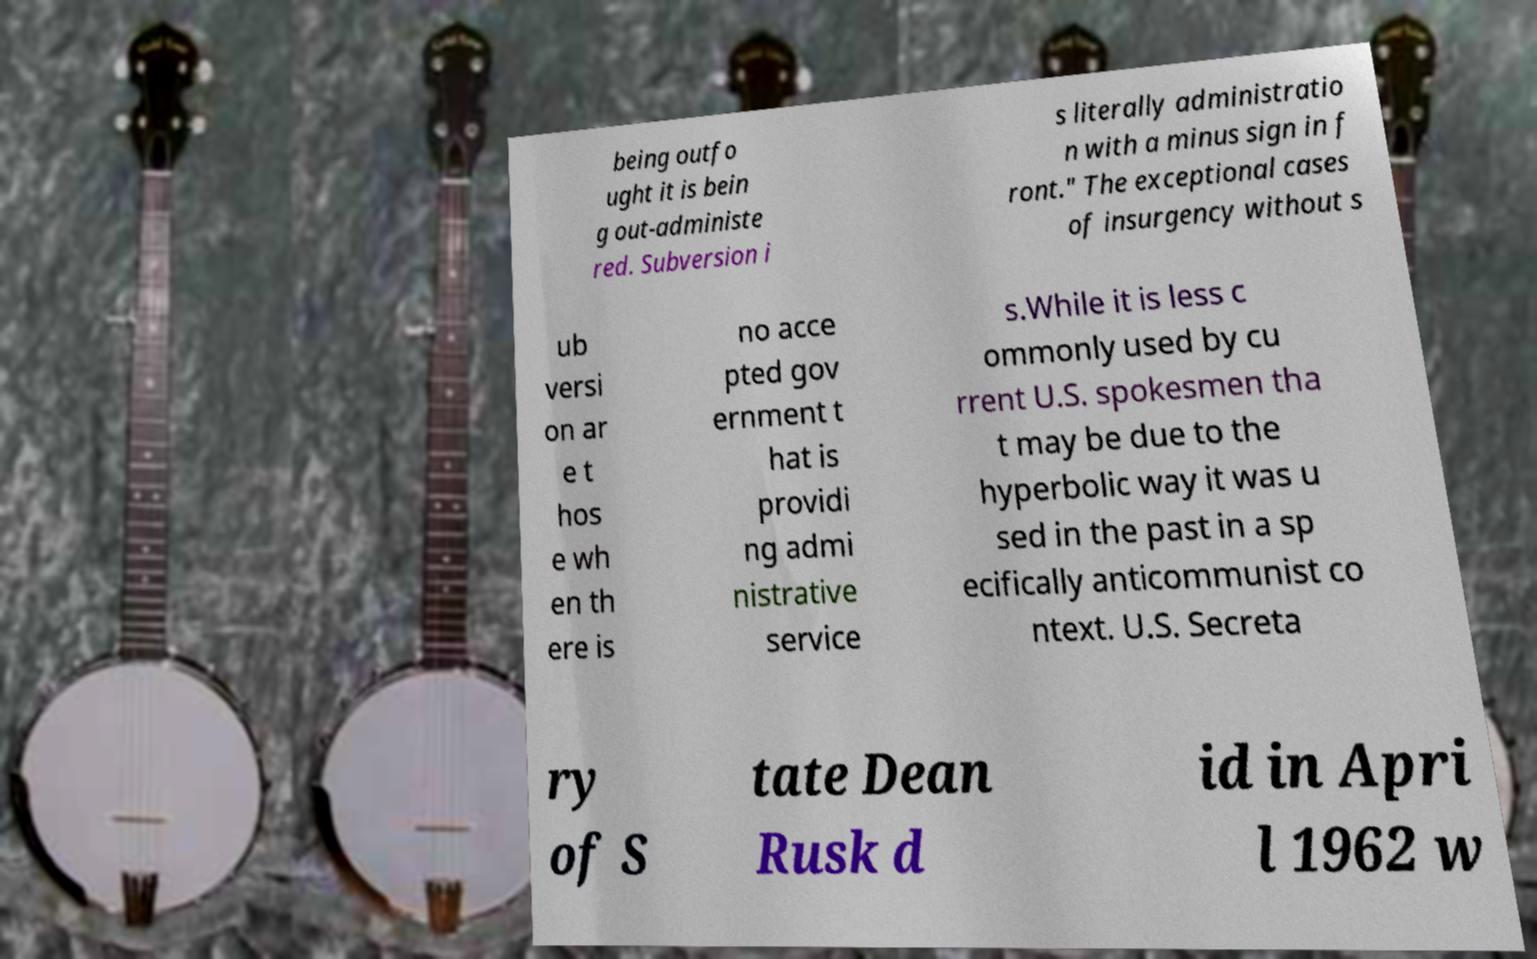For documentation purposes, I need the text within this image transcribed. Could you provide that? being outfo ught it is bein g out-administe red. Subversion i s literally administratio n with a minus sign in f ront." The exceptional cases of insurgency without s ub versi on ar e t hos e wh en th ere is no acce pted gov ernment t hat is providi ng admi nistrative service s.While it is less c ommonly used by cu rrent U.S. spokesmen tha t may be due to the hyperbolic way it was u sed in the past in a sp ecifically anticommunist co ntext. U.S. Secreta ry of S tate Dean Rusk d id in Apri l 1962 w 